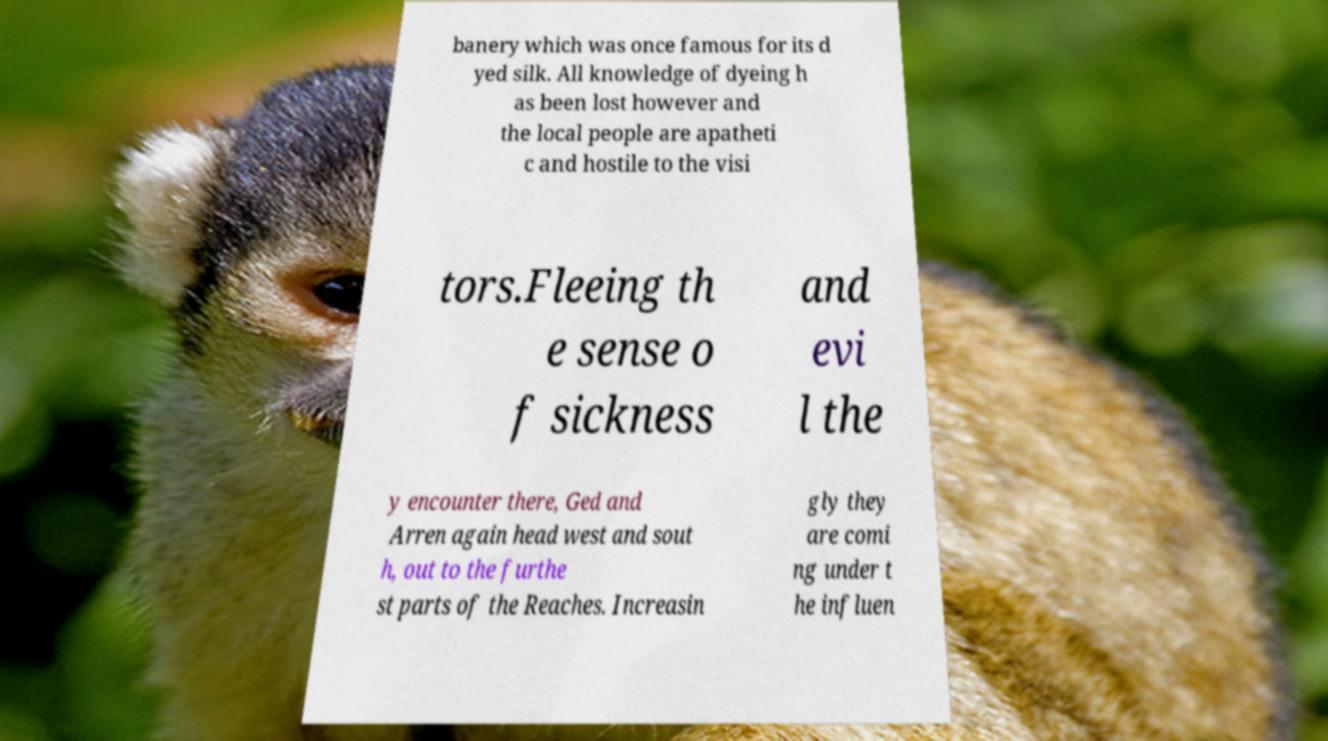Please identify and transcribe the text found in this image. banery which was once famous for its d yed silk. All knowledge of dyeing h as been lost however and the local people are apatheti c and hostile to the visi tors.Fleeing th e sense o f sickness and evi l the y encounter there, Ged and Arren again head west and sout h, out to the furthe st parts of the Reaches. Increasin gly they are comi ng under t he influen 